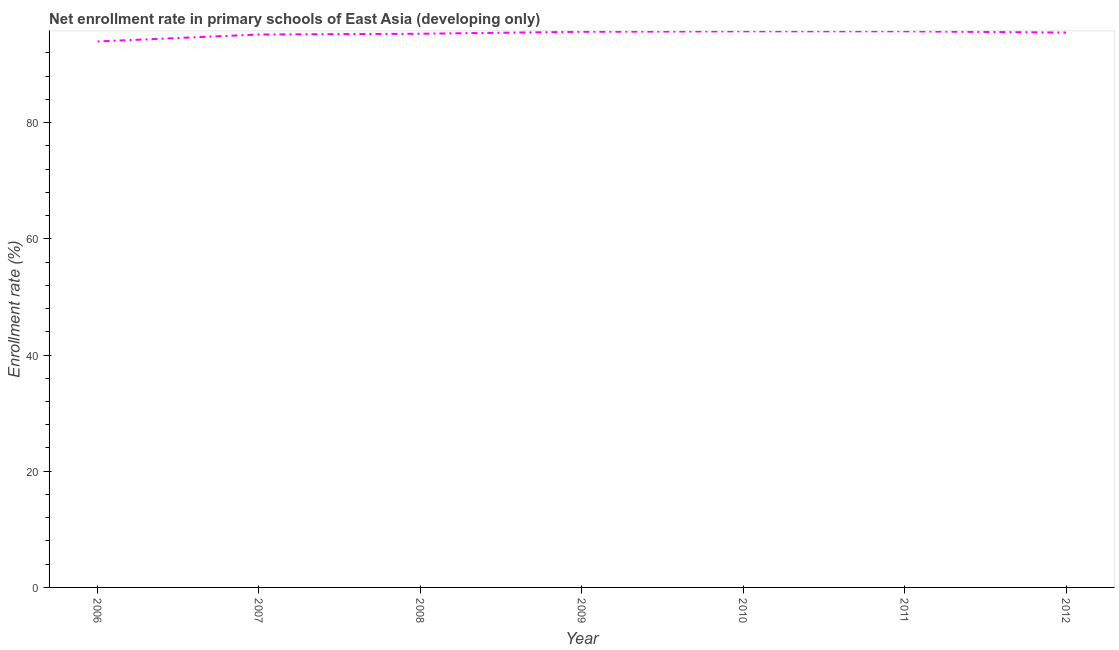What is the net enrollment rate in primary schools in 2010?
Offer a very short reply. 95.72. Across all years, what is the maximum net enrollment rate in primary schools?
Provide a succinct answer. 95.72. Across all years, what is the minimum net enrollment rate in primary schools?
Your answer should be compact. 93.97. What is the sum of the net enrollment rate in primary schools?
Your answer should be very brief. 667.04. What is the difference between the net enrollment rate in primary schools in 2008 and 2011?
Your answer should be very brief. -0.42. What is the average net enrollment rate in primary schools per year?
Your answer should be compact. 95.29. What is the median net enrollment rate in primary schools?
Offer a very short reply. 95.51. In how many years, is the net enrollment rate in primary schools greater than 48 %?
Provide a succinct answer. 7. What is the ratio of the net enrollment rate in primary schools in 2008 to that in 2012?
Ensure brevity in your answer.  1. What is the difference between the highest and the second highest net enrollment rate in primary schools?
Provide a succinct answer. 0. Is the sum of the net enrollment rate in primary schools in 2006 and 2009 greater than the maximum net enrollment rate in primary schools across all years?
Your response must be concise. Yes. What is the difference between the highest and the lowest net enrollment rate in primary schools?
Offer a very short reply. 1.75. Are the values on the major ticks of Y-axis written in scientific E-notation?
Make the answer very short. No. Does the graph contain any zero values?
Give a very brief answer. No. What is the title of the graph?
Your answer should be very brief. Net enrollment rate in primary schools of East Asia (developing only). What is the label or title of the X-axis?
Your answer should be very brief. Year. What is the label or title of the Y-axis?
Make the answer very short. Enrollment rate (%). What is the Enrollment rate (%) in 2006?
Your answer should be compact. 93.97. What is the Enrollment rate (%) in 2007?
Make the answer very short. 95.18. What is the Enrollment rate (%) in 2008?
Make the answer very short. 95.3. What is the Enrollment rate (%) in 2009?
Your response must be concise. 95.64. What is the Enrollment rate (%) of 2010?
Offer a terse response. 95.72. What is the Enrollment rate (%) in 2011?
Offer a terse response. 95.72. What is the Enrollment rate (%) of 2012?
Offer a terse response. 95.51. What is the difference between the Enrollment rate (%) in 2006 and 2007?
Your response must be concise. -1.2. What is the difference between the Enrollment rate (%) in 2006 and 2008?
Offer a very short reply. -1.33. What is the difference between the Enrollment rate (%) in 2006 and 2009?
Keep it short and to the point. -1.67. What is the difference between the Enrollment rate (%) in 2006 and 2010?
Keep it short and to the point. -1.74. What is the difference between the Enrollment rate (%) in 2006 and 2011?
Offer a very short reply. -1.75. What is the difference between the Enrollment rate (%) in 2006 and 2012?
Your response must be concise. -1.53. What is the difference between the Enrollment rate (%) in 2007 and 2008?
Give a very brief answer. -0.13. What is the difference between the Enrollment rate (%) in 2007 and 2009?
Keep it short and to the point. -0.47. What is the difference between the Enrollment rate (%) in 2007 and 2010?
Your answer should be very brief. -0.54. What is the difference between the Enrollment rate (%) in 2007 and 2011?
Make the answer very short. -0.54. What is the difference between the Enrollment rate (%) in 2007 and 2012?
Offer a terse response. -0.33. What is the difference between the Enrollment rate (%) in 2008 and 2009?
Offer a very short reply. -0.34. What is the difference between the Enrollment rate (%) in 2008 and 2010?
Offer a terse response. -0.41. What is the difference between the Enrollment rate (%) in 2008 and 2011?
Offer a very short reply. -0.42. What is the difference between the Enrollment rate (%) in 2008 and 2012?
Your response must be concise. -0.2. What is the difference between the Enrollment rate (%) in 2009 and 2010?
Give a very brief answer. -0.07. What is the difference between the Enrollment rate (%) in 2009 and 2011?
Make the answer very short. -0.08. What is the difference between the Enrollment rate (%) in 2009 and 2012?
Keep it short and to the point. 0.14. What is the difference between the Enrollment rate (%) in 2010 and 2011?
Provide a short and direct response. -0. What is the difference between the Enrollment rate (%) in 2010 and 2012?
Provide a short and direct response. 0.21. What is the difference between the Enrollment rate (%) in 2011 and 2012?
Your answer should be compact. 0.21. What is the ratio of the Enrollment rate (%) in 2006 to that in 2008?
Your response must be concise. 0.99. What is the ratio of the Enrollment rate (%) in 2006 to that in 2009?
Your response must be concise. 0.98. What is the ratio of the Enrollment rate (%) in 2006 to that in 2010?
Your response must be concise. 0.98. What is the ratio of the Enrollment rate (%) in 2006 to that in 2011?
Offer a terse response. 0.98. What is the ratio of the Enrollment rate (%) in 2007 to that in 2009?
Your answer should be compact. 0.99. What is the ratio of the Enrollment rate (%) in 2008 to that in 2010?
Your answer should be very brief. 1. What is the ratio of the Enrollment rate (%) in 2008 to that in 2012?
Your answer should be very brief. 1. What is the ratio of the Enrollment rate (%) in 2009 to that in 2011?
Keep it short and to the point. 1. What is the ratio of the Enrollment rate (%) in 2010 to that in 2012?
Your response must be concise. 1. 